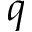Convert formula to latex. <formula><loc_0><loc_0><loc_500><loc_500>q</formula> 